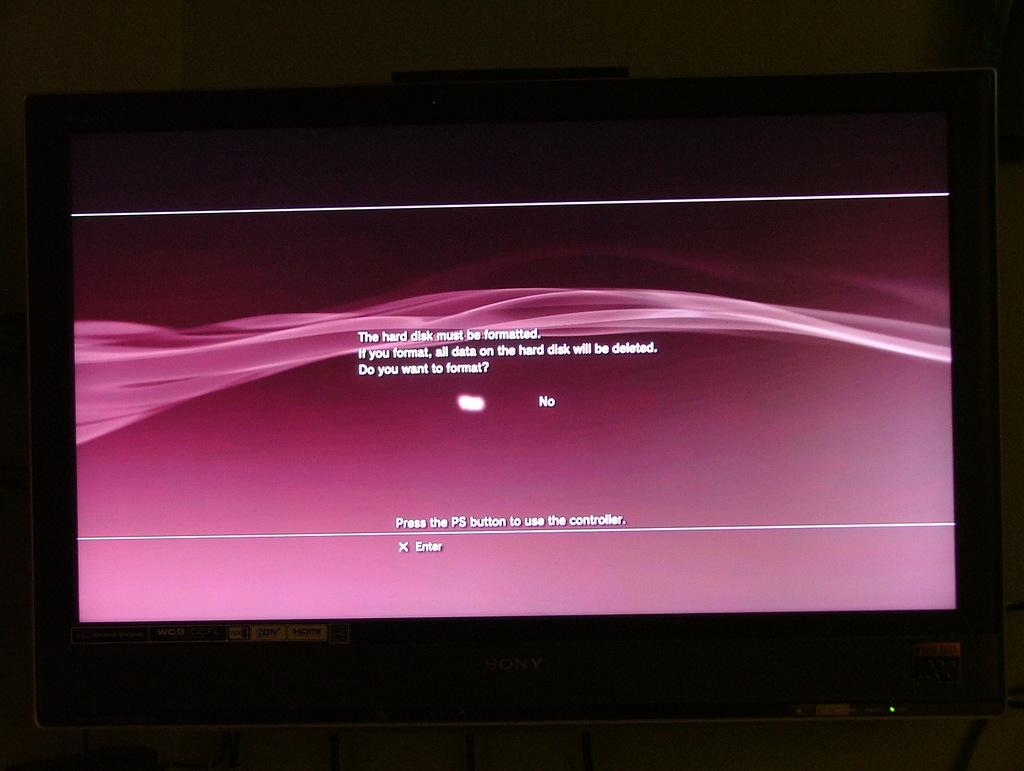<image>
Write a terse but informative summary of the picture. A television displaying text that reads the hard drive must be formatted with options for yes and no. 